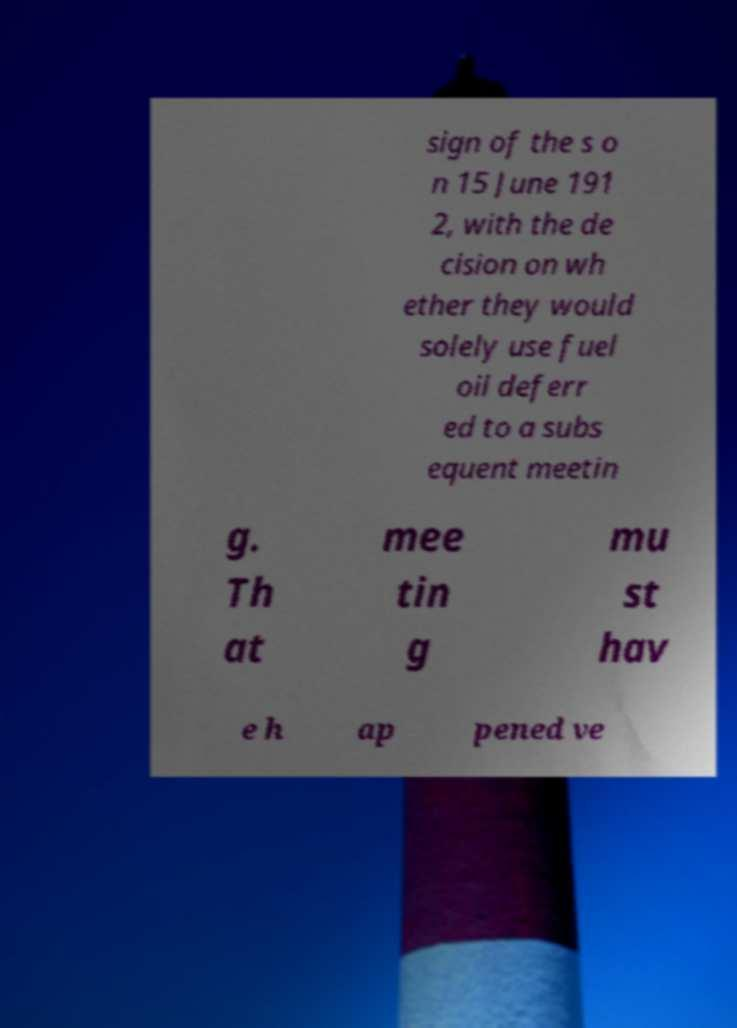For documentation purposes, I need the text within this image transcribed. Could you provide that? sign of the s o n 15 June 191 2, with the de cision on wh ether they would solely use fuel oil deferr ed to a subs equent meetin g. Th at mee tin g mu st hav e h ap pened ve 